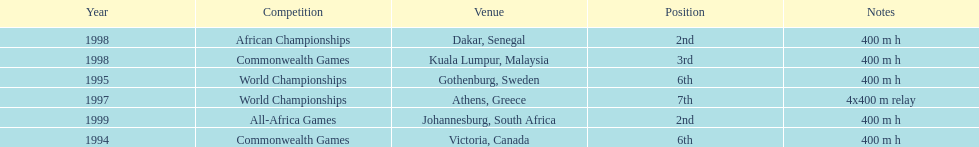What is the total number of competitions on this chart? 6. 